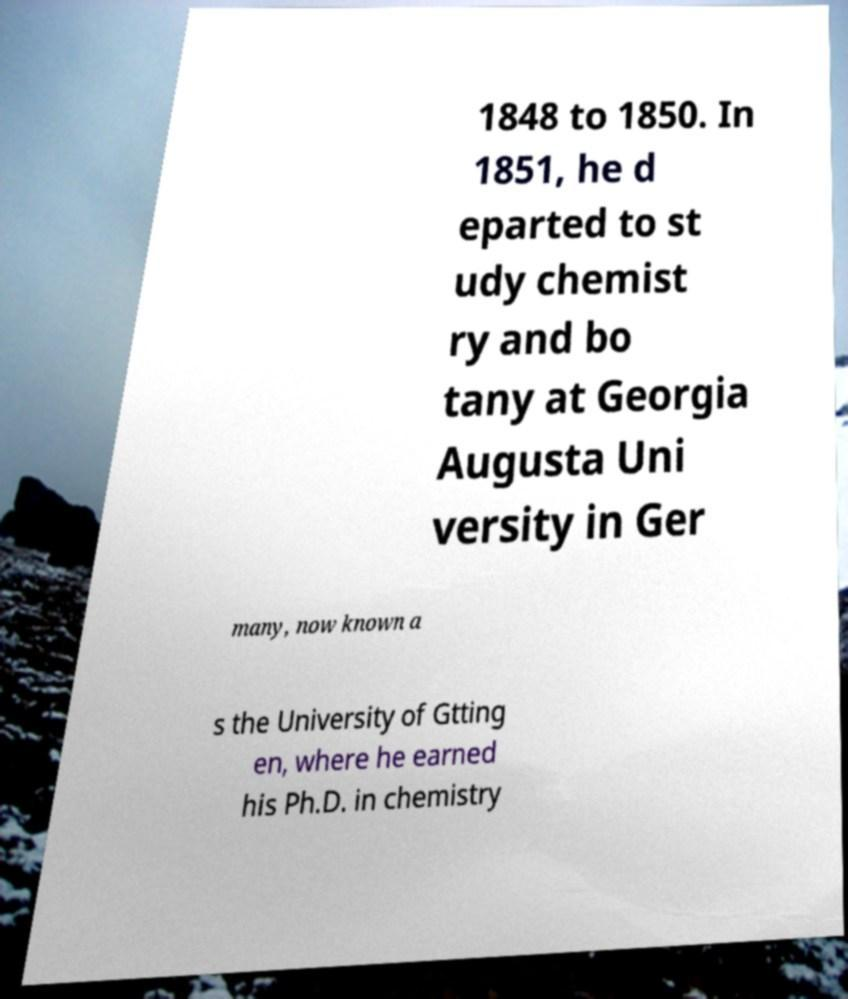For documentation purposes, I need the text within this image transcribed. Could you provide that? 1848 to 1850. In 1851, he d eparted to st udy chemist ry and bo tany at Georgia Augusta Uni versity in Ger many, now known a s the University of Gtting en, where he earned his Ph.D. in chemistry 